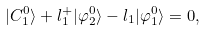<formula> <loc_0><loc_0><loc_500><loc_500>| C ^ { 0 } _ { 1 } \rangle + l _ { 1 } ^ { + } | \varphi ^ { 0 } _ { 2 } \rangle - l _ { 1 } | \varphi ^ { 0 } _ { 1 } \rangle = 0 ,</formula> 